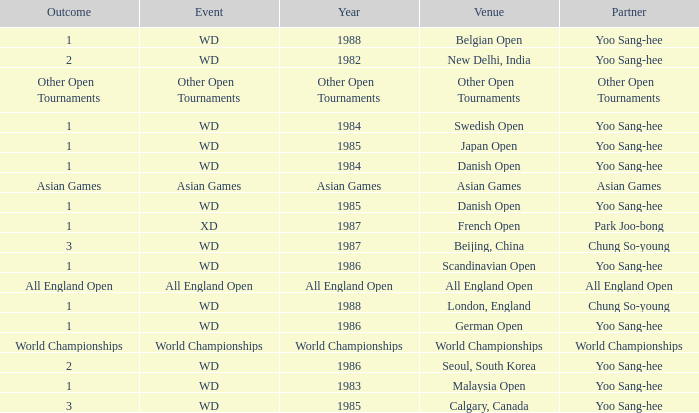Could you help me parse every detail presented in this table? {'header': ['Outcome', 'Event', 'Year', 'Venue', 'Partner'], 'rows': [['1', 'WD', '1988', 'Belgian Open', 'Yoo Sang-hee'], ['2', 'WD', '1982', 'New Delhi, India', 'Yoo Sang-hee'], ['Other Open Tournaments', 'Other Open Tournaments', 'Other Open Tournaments', 'Other Open Tournaments', 'Other Open Tournaments'], ['1', 'WD', '1984', 'Swedish Open', 'Yoo Sang-hee'], ['1', 'WD', '1985', 'Japan Open', 'Yoo Sang-hee'], ['1', 'WD', '1984', 'Danish Open', 'Yoo Sang-hee'], ['Asian Games', 'Asian Games', 'Asian Games', 'Asian Games', 'Asian Games'], ['1', 'WD', '1985', 'Danish Open', 'Yoo Sang-hee'], ['1', 'XD', '1987', 'French Open', 'Park Joo-bong'], ['3', 'WD', '1987', 'Beijing, China', 'Chung So-young'], ['1', 'WD', '1986', 'Scandinavian Open', 'Yoo Sang-hee'], ['All England Open', 'All England Open', 'All England Open', 'All England Open', 'All England Open'], ['1', 'WD', '1988', 'London, England', 'Chung So-young'], ['1', 'WD', '1986', 'German Open', 'Yoo Sang-hee'], ['World Championships', 'World Championships', 'World Championships', 'World Championships', 'World Championships'], ['2', 'WD', '1986', 'Seoul, South Korea', 'Yoo Sang-hee'], ['1', 'WD', '1983', 'Malaysia Open', 'Yoo Sang-hee'], ['3', 'WD', '1985', 'Calgary, Canada', 'Yoo Sang-hee']]} What was the Venue in 1986 with an Outcome of 1? Scandinavian Open, German Open. 